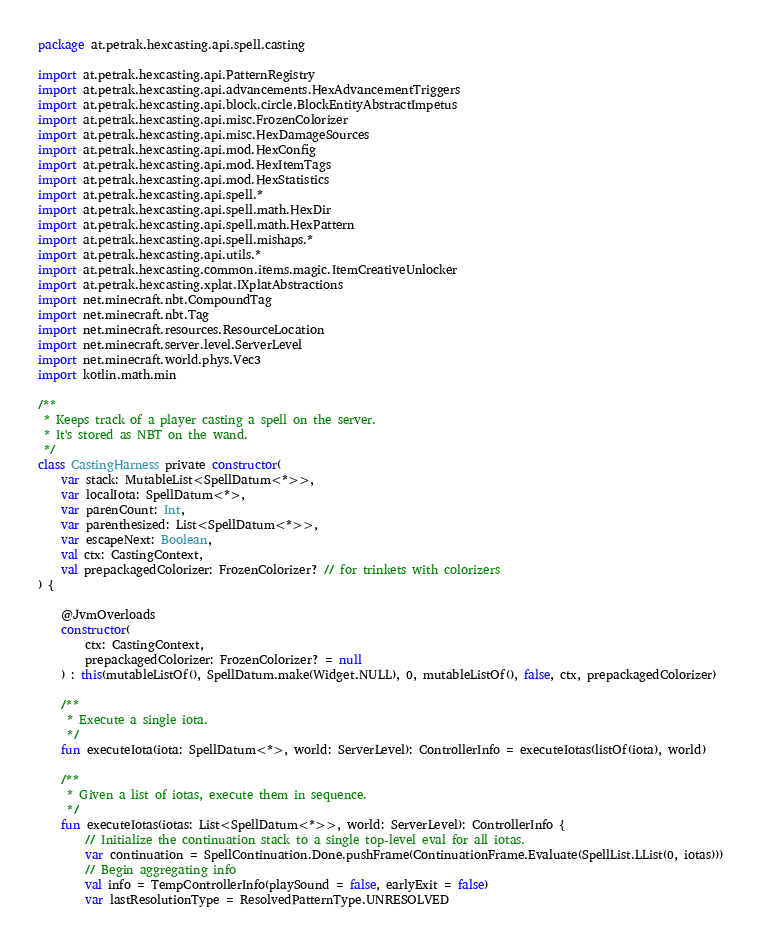Convert code to text. <code><loc_0><loc_0><loc_500><loc_500><_Kotlin_>package at.petrak.hexcasting.api.spell.casting

import at.petrak.hexcasting.api.PatternRegistry
import at.petrak.hexcasting.api.advancements.HexAdvancementTriggers
import at.petrak.hexcasting.api.block.circle.BlockEntityAbstractImpetus
import at.petrak.hexcasting.api.misc.FrozenColorizer
import at.petrak.hexcasting.api.misc.HexDamageSources
import at.petrak.hexcasting.api.mod.HexConfig
import at.petrak.hexcasting.api.mod.HexItemTags
import at.petrak.hexcasting.api.mod.HexStatistics
import at.petrak.hexcasting.api.spell.*
import at.petrak.hexcasting.api.spell.math.HexDir
import at.petrak.hexcasting.api.spell.math.HexPattern
import at.petrak.hexcasting.api.spell.mishaps.*
import at.petrak.hexcasting.api.utils.*
import at.petrak.hexcasting.common.items.magic.ItemCreativeUnlocker
import at.petrak.hexcasting.xplat.IXplatAbstractions
import net.minecraft.nbt.CompoundTag
import net.minecraft.nbt.Tag
import net.minecraft.resources.ResourceLocation
import net.minecraft.server.level.ServerLevel
import net.minecraft.world.phys.Vec3
import kotlin.math.min

/**
 * Keeps track of a player casting a spell on the server.
 * It's stored as NBT on the wand.
 */
class CastingHarness private constructor(
    var stack: MutableList<SpellDatum<*>>,
    var localIota: SpellDatum<*>,
    var parenCount: Int,
    var parenthesized: List<SpellDatum<*>>,
    var escapeNext: Boolean,
    val ctx: CastingContext,
    val prepackagedColorizer: FrozenColorizer? // for trinkets with colorizers
) {

    @JvmOverloads
    constructor(
        ctx: CastingContext,
        prepackagedColorizer: FrozenColorizer? = null
    ) : this(mutableListOf(), SpellDatum.make(Widget.NULL), 0, mutableListOf(), false, ctx, prepackagedColorizer)

    /**
     * Execute a single iota.
     */
    fun executeIota(iota: SpellDatum<*>, world: ServerLevel): ControllerInfo = executeIotas(listOf(iota), world)

    /**
     * Given a list of iotas, execute them in sequence.
     */
    fun executeIotas(iotas: List<SpellDatum<*>>, world: ServerLevel): ControllerInfo {
        // Initialize the continuation stack to a single top-level eval for all iotas.
        var continuation = SpellContinuation.Done.pushFrame(ContinuationFrame.Evaluate(SpellList.LList(0, iotas)))
        // Begin aggregating info
        val info = TempControllerInfo(playSound = false, earlyExit = false)
        var lastResolutionType = ResolvedPatternType.UNRESOLVED</code> 